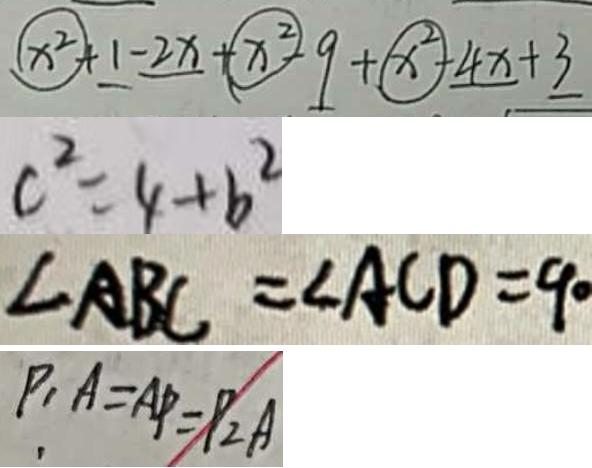<formula> <loc_0><loc_0><loc_500><loc_500>x ^ { 2 } + 1 - 2 x + x ^ { 2 } - 9 + x ^ { 2 } - 4 x + 3 
 c ^ { 2 } = 4 + b ^ { 2 } 
 \angle A B C = \angle A C D = 9 0 
 P _ { 1 } A = A P = P _ { 2 } A</formula> 